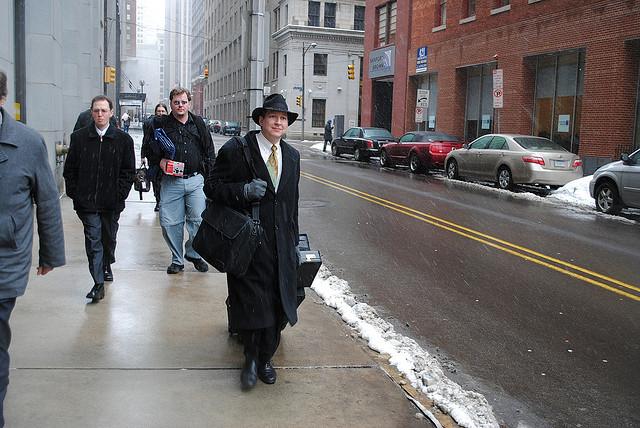What are the lines in the street for?
Write a very short answer. Dividing. What color is the man's tie?
Give a very brief answer. Yellow. Is there snow on the ground?
Concise answer only. Yes. Is the man in the hat wearing gloves?
Answer briefly. Yes. Where are they going?
Keep it brief. Work. 